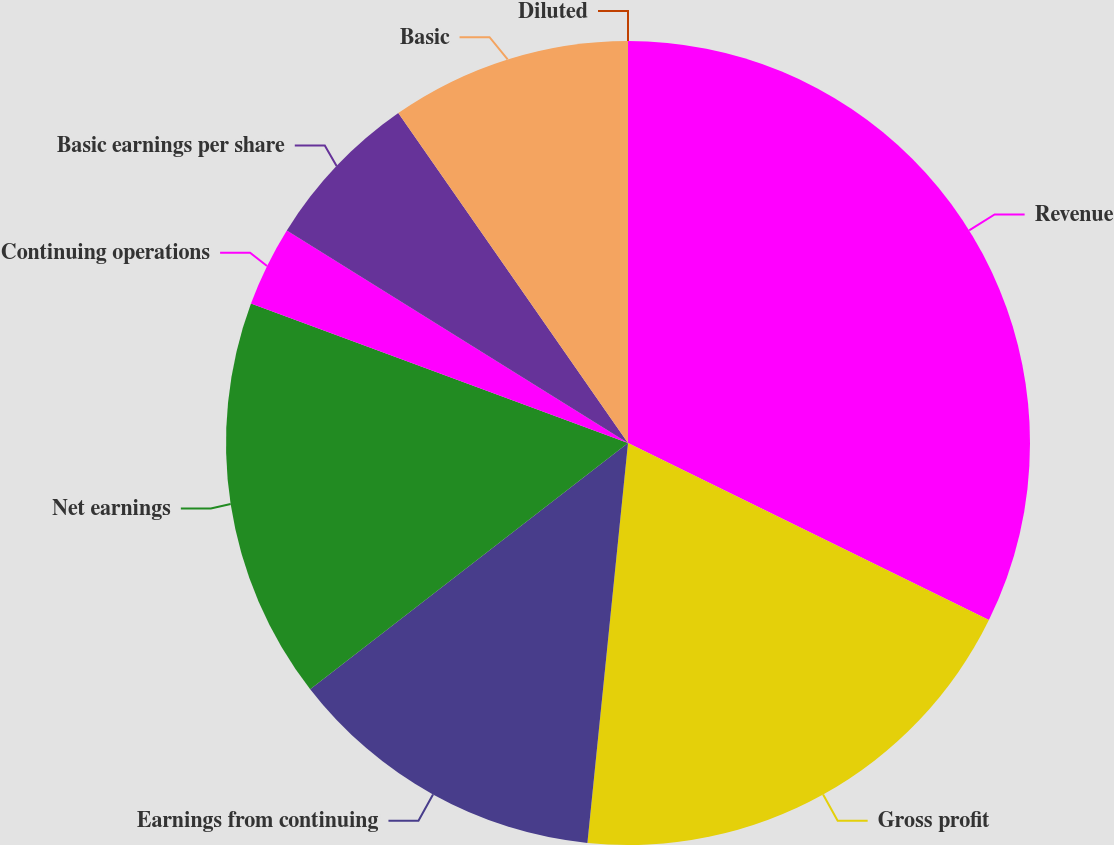<chart> <loc_0><loc_0><loc_500><loc_500><pie_chart><fcel>Revenue<fcel>Gross profit<fcel>Earnings from continuing<fcel>Net earnings<fcel>Continuing operations<fcel>Basic earnings per share<fcel>Basic<fcel>Diluted<nl><fcel>32.26%<fcel>19.35%<fcel>12.9%<fcel>16.13%<fcel>3.23%<fcel>6.45%<fcel>9.68%<fcel>0.0%<nl></chart> 